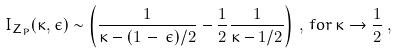<formula> <loc_0><loc_0><loc_500><loc_500>I _ { Z _ { P } } ( \kappa , \epsilon ) \sim \left ( \frac { 1 } { \kappa - ( 1 \, - \, \epsilon ) / 2 } - \frac { 1 } { 2 } \frac { 1 } { \kappa - 1 / 2 } \right ) \, , \, f o r \, \kappa \to \frac { 1 } { 2 } \, ,</formula> 